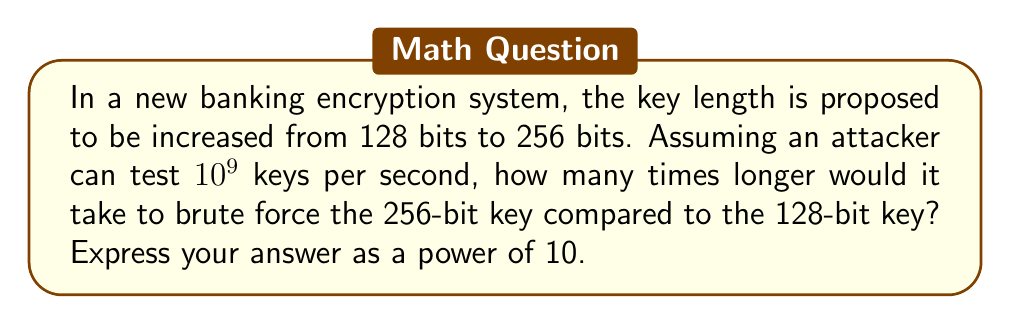Help me with this question. Let's approach this step-by-step:

1) For a 128-bit key, the total number of possible keys is:
   $$2^{128}$$

2) For a 256-bit key, the total number of possible keys is:
   $$2^{256}$$

3) The time to brute force a 128-bit key (in seconds) is:
   $$T_{128} = \frac{2^{128}}{10^9}$$

4) The time to brute force a 256-bit key (in seconds) is:
   $$T_{256} = \frac{2^{256}}{10^9}$$

5) The ratio of these times is:
   $$\frac{T_{256}}{T_{128}} = \frac{2^{256}/10^9}{2^{128}/10^9} = \frac{2^{256}}{2^{128}} = 2^{128}$$

6) We need to express this as a power of 10. We can use the property:
   $$2^{128} = (2^{10})^{12.8} \approx 1024^{12.8} \approx 10^{38.5}$$

7) Therefore, it would take approximately $10^{38.5}$ times longer to brute force the 256-bit key.
Answer: $10^{38.5}$ 